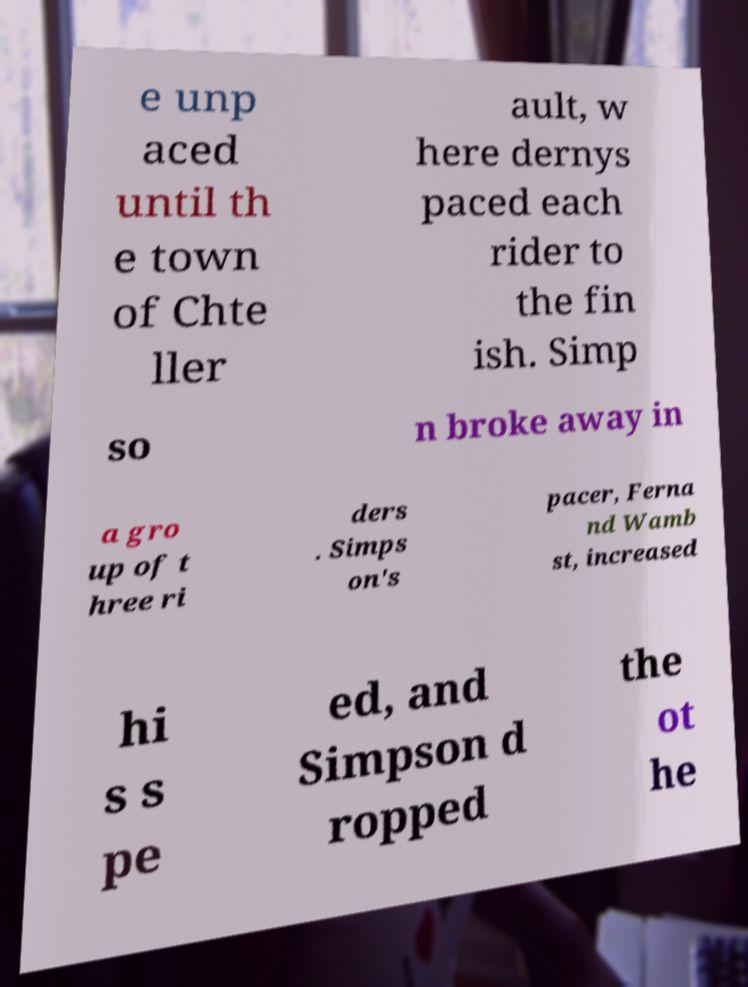Could you assist in decoding the text presented in this image and type it out clearly? e unp aced until th e town of Chte ller ault, w here dernys paced each rider to the fin ish. Simp so n broke away in a gro up of t hree ri ders . Simps on's pacer, Ferna nd Wamb st, increased hi s s pe ed, and Simpson d ropped the ot he 